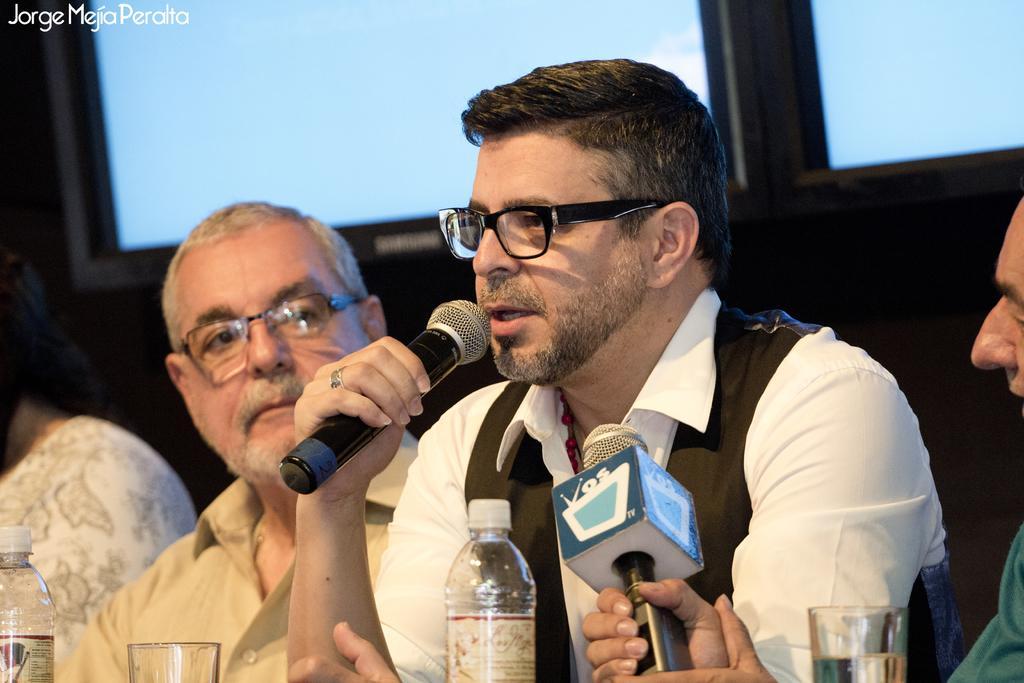Can you describe this image briefly? This picture is clicked in a conference hall. Here, we see four people sitting on chair. Man in white shirt wearing black coat is holding microphone in his hands and his talking on it. He is even wearing spectacles. Beside him, we see man in cream shirt is also wearing spectacles. In front of him, we see a table on which water bottle, glass is placed and on the right corner of the picture, we see man in green shirt is holding microphone in his hands. 